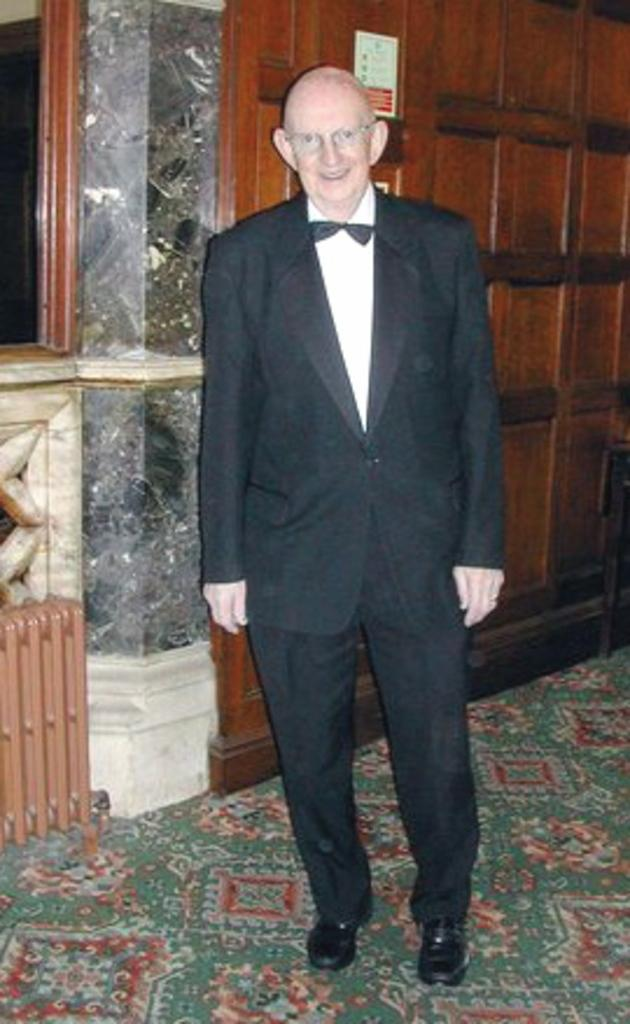Who or what is present in the image? There is a person in the image. What is the person wearing? The person is wearing clothes. What is behind the person in the image? The person is standing in front of a wall. What type of polish is the person applying to their drum in the image? There is no drum or polish present in the image; it only features a person standing in front of a wall. 